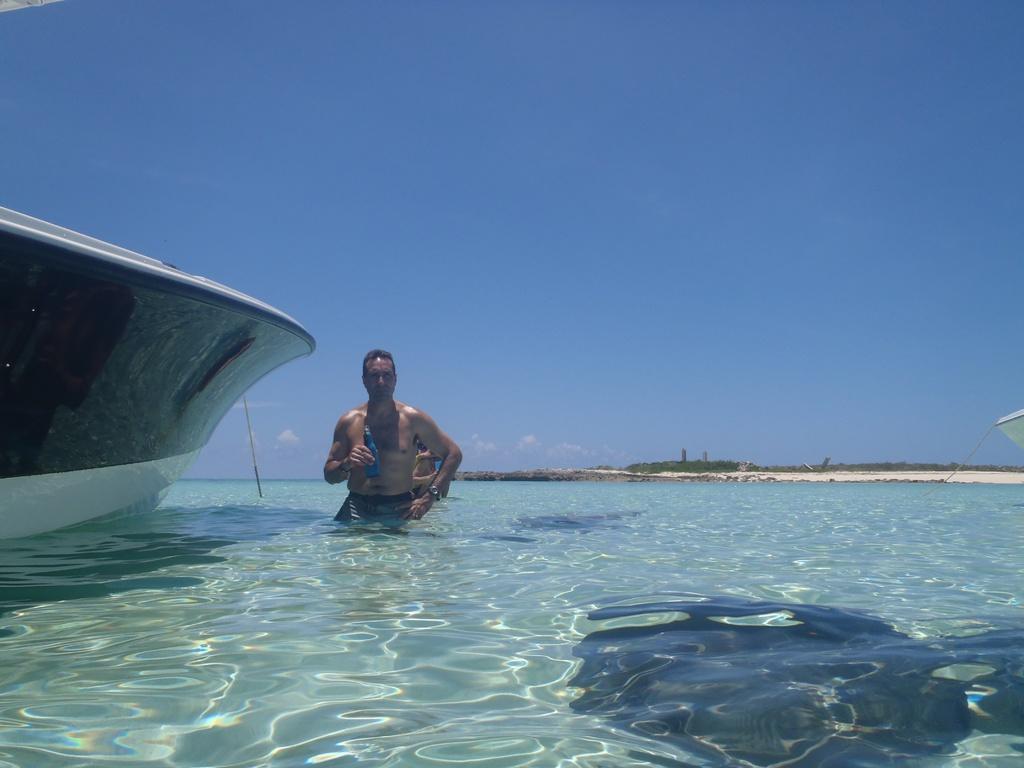How would you summarize this image in a sentence or two? In this image, there are two people in the water. On the left side of the image, I can see a boat on the water. In the background, there are trees and the sky. 